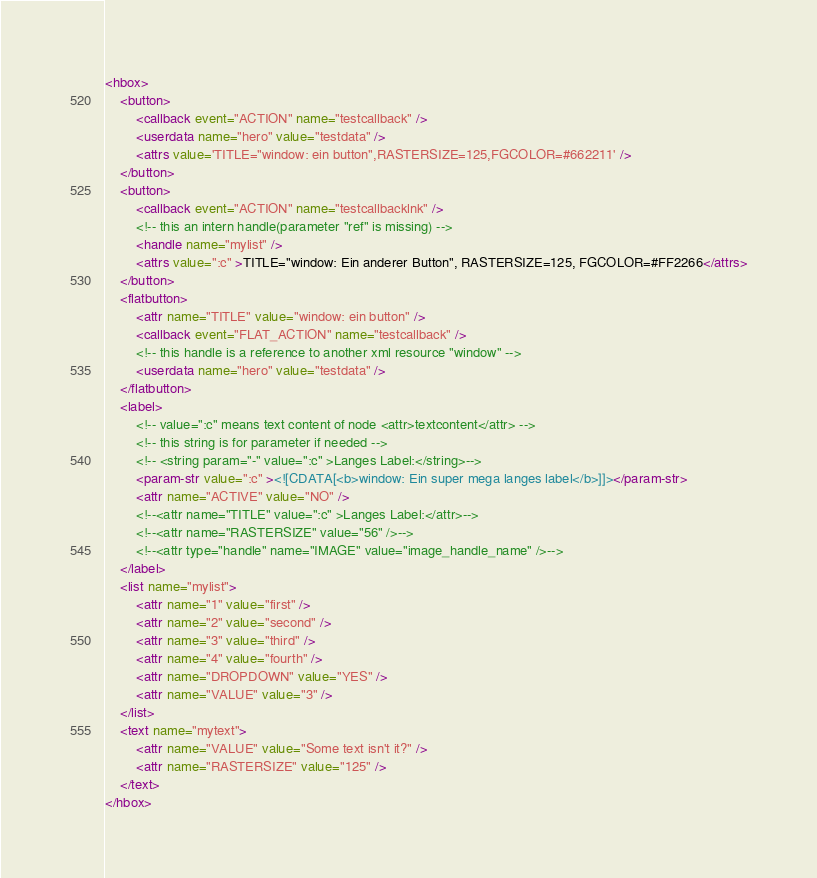<code> <loc_0><loc_0><loc_500><loc_500><_XML_><hbox>
    <button>
        <callback event="ACTION" name="testcallback" />
        <userdata name="hero" value="testdata" />
        <attrs value='TITLE="window: ein button",RASTERSIZE=125,FGCOLOR=#662211' />
    </button>
    <button>
        <callback event="ACTION" name="testcallbacklnk" />
        <!-- this an intern handle(parameter "ref" is missing) -->
        <handle name="mylist" />
        <attrs value=":c" >TITLE="window: Ein anderer Button", RASTERSIZE=125, FGCOLOR=#FF2266</attrs>
    </button>
    <flatbutton>
        <attr name="TITLE" value="window: ein button" />
        <callback event="FLAT_ACTION" name="testcallback" />
        <!-- this handle is a reference to another xml resource "window" -->
        <userdata name="hero" value="testdata" />
    </flatbutton>
    <label>
        <!-- value=":c" means text content of node <attr>textcontent</attr> -->
        <!-- this string is for parameter if needed -->
        <!-- <string param="-" value=":c" >Langes Label:</string>-->
        <param-str value=":c" ><![CDATA[<b>window: Ein super mega langes label</b>]]></param-str>
        <attr name="ACTIVE" value="NO" />
        <!--<attr name="TITLE" value=":c" >Langes Label:</attr>-->
        <!--<attr name="RASTERSIZE" value="56" />-->
        <!--<attr type="handle" name="IMAGE" value="image_handle_name" />-->
    </label>
    <list name="mylist">
        <attr name="1" value="first" />
        <attr name="2" value="second" />
        <attr name="3" value="third" />
        <attr name="4" value="fourth" />
        <attr name="DROPDOWN" value="YES" />
        <attr name="VALUE" value="3" />
    </list>
    <text name="mytext">
        <attr name="VALUE" value="Some text isn't it?" />
        <attr name="RASTERSIZE" value="125" />
    </text>
</hbox>

</code> 